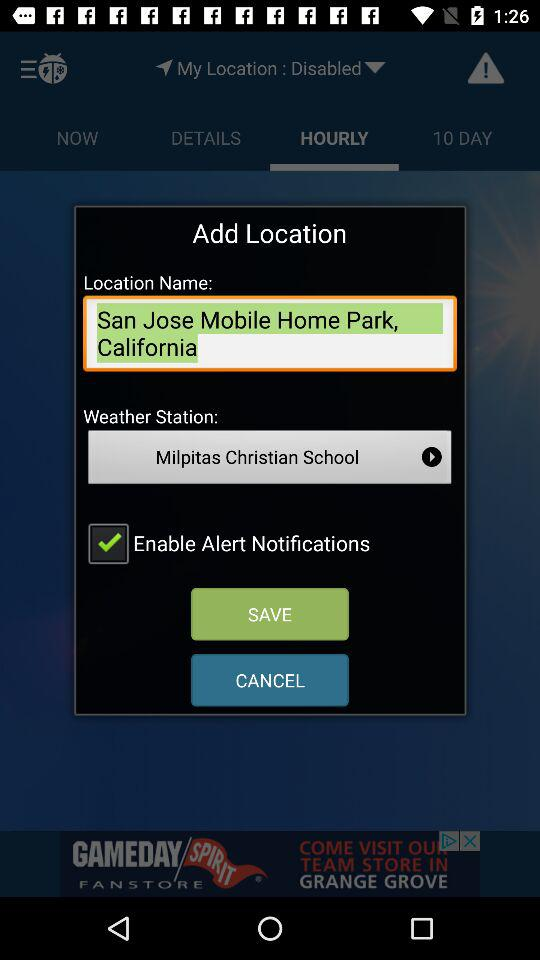What is the location name? The location name is San Jose Mobile Home Park, California. 